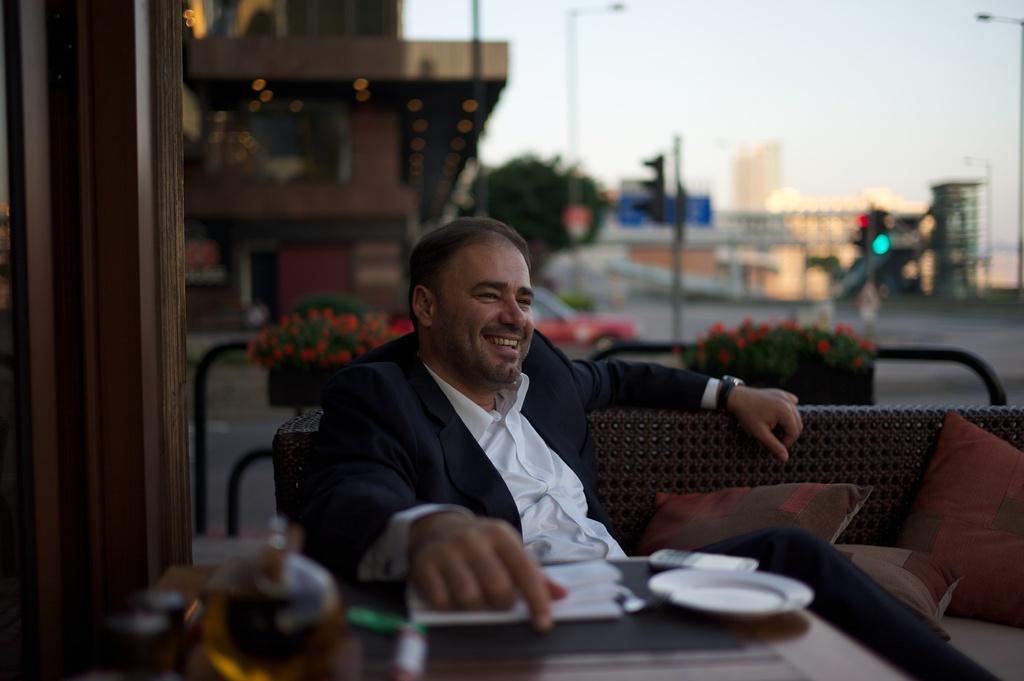Could you give a brief overview of what you see in this image? A man is sitting on the sofa and resting his hands on a dining table and he is smiling behind him there is a vehicle moving on the road. It's a building and there is a traffic signal. 